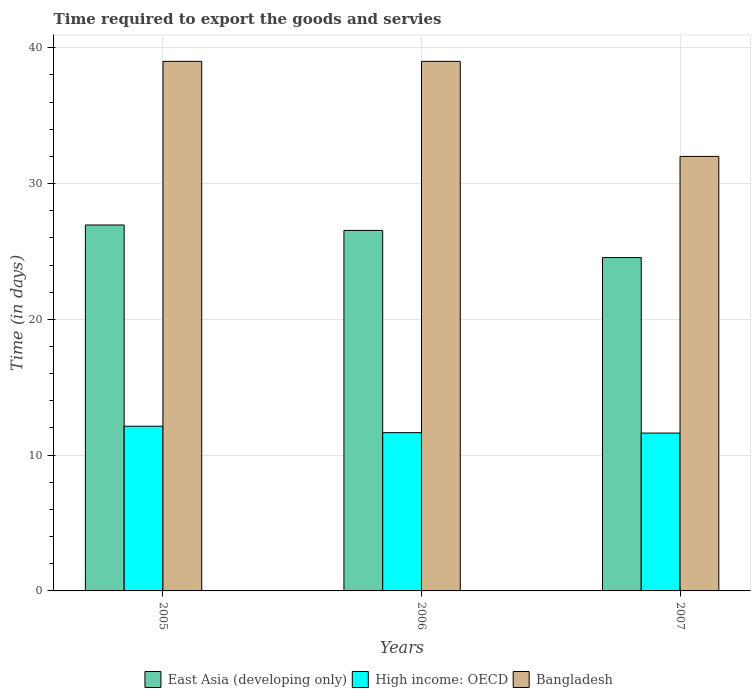Are the number of bars per tick equal to the number of legend labels?
Offer a very short reply. Yes. How many bars are there on the 3rd tick from the left?
Make the answer very short. 3. What is the label of the 1st group of bars from the left?
Your answer should be compact. 2005. In how many cases, is the number of bars for a given year not equal to the number of legend labels?
Offer a terse response. 0. What is the number of days required to export the goods and services in High income: OECD in 2006?
Give a very brief answer. 11.66. Across all years, what is the minimum number of days required to export the goods and services in High income: OECD?
Give a very brief answer. 11.62. In which year was the number of days required to export the goods and services in Bangladesh maximum?
Offer a very short reply. 2005. In which year was the number of days required to export the goods and services in East Asia (developing only) minimum?
Keep it short and to the point. 2007. What is the total number of days required to export the goods and services in High income: OECD in the graph?
Keep it short and to the point. 35.41. What is the difference between the number of days required to export the goods and services in High income: OECD in 2005 and that in 2007?
Ensure brevity in your answer.  0.5. What is the difference between the number of days required to export the goods and services in Bangladesh in 2005 and the number of days required to export the goods and services in High income: OECD in 2006?
Provide a succinct answer. 27.34. What is the average number of days required to export the goods and services in Bangladesh per year?
Ensure brevity in your answer.  36.67. In the year 2007, what is the difference between the number of days required to export the goods and services in East Asia (developing only) and number of days required to export the goods and services in Bangladesh?
Your answer should be very brief. -7.45. In how many years, is the number of days required to export the goods and services in East Asia (developing only) greater than 32 days?
Give a very brief answer. 0. What is the ratio of the number of days required to export the goods and services in East Asia (developing only) in 2005 to that in 2006?
Offer a terse response. 1.02. What is the difference between the highest and the lowest number of days required to export the goods and services in High income: OECD?
Offer a very short reply. 0.5. What does the 2nd bar from the right in 2006 represents?
Make the answer very short. High income: OECD. How many bars are there?
Give a very brief answer. 9. How many years are there in the graph?
Provide a succinct answer. 3. Are the values on the major ticks of Y-axis written in scientific E-notation?
Offer a very short reply. No. Does the graph contain any zero values?
Provide a succinct answer. No. Where does the legend appear in the graph?
Your answer should be compact. Bottom center. How many legend labels are there?
Make the answer very short. 3. What is the title of the graph?
Provide a succinct answer. Time required to export the goods and servies. What is the label or title of the Y-axis?
Provide a succinct answer. Time (in days). What is the Time (in days) of East Asia (developing only) in 2005?
Your answer should be compact. 26.95. What is the Time (in days) of High income: OECD in 2005?
Provide a short and direct response. 12.13. What is the Time (in days) in Bangladesh in 2005?
Your response must be concise. 39. What is the Time (in days) of East Asia (developing only) in 2006?
Provide a succinct answer. 26.55. What is the Time (in days) of High income: OECD in 2006?
Ensure brevity in your answer.  11.66. What is the Time (in days) of East Asia (developing only) in 2007?
Keep it short and to the point. 24.55. What is the Time (in days) of High income: OECD in 2007?
Your answer should be very brief. 11.62. What is the Time (in days) in Bangladesh in 2007?
Offer a very short reply. 32. Across all years, what is the maximum Time (in days) of East Asia (developing only)?
Offer a very short reply. 26.95. Across all years, what is the maximum Time (in days) of High income: OECD?
Provide a short and direct response. 12.13. Across all years, what is the maximum Time (in days) of Bangladesh?
Your answer should be very brief. 39. Across all years, what is the minimum Time (in days) of East Asia (developing only)?
Give a very brief answer. 24.55. Across all years, what is the minimum Time (in days) of High income: OECD?
Ensure brevity in your answer.  11.62. Across all years, what is the minimum Time (in days) in Bangladesh?
Your answer should be very brief. 32. What is the total Time (in days) of East Asia (developing only) in the graph?
Keep it short and to the point. 78.05. What is the total Time (in days) of High income: OECD in the graph?
Provide a succinct answer. 35.41. What is the total Time (in days) in Bangladesh in the graph?
Your response must be concise. 110. What is the difference between the Time (in days) in High income: OECD in 2005 and that in 2006?
Your answer should be very brief. 0.47. What is the difference between the Time (in days) of Bangladesh in 2005 and that in 2006?
Ensure brevity in your answer.  0. What is the difference between the Time (in days) of East Asia (developing only) in 2005 and that in 2007?
Give a very brief answer. 2.4. What is the difference between the Time (in days) in High income: OECD in 2005 and that in 2007?
Provide a succinct answer. 0.5. What is the difference between the Time (in days) in Bangladesh in 2005 and that in 2007?
Your response must be concise. 7. What is the difference between the Time (in days) of East Asia (developing only) in 2006 and that in 2007?
Provide a succinct answer. 2. What is the difference between the Time (in days) in High income: OECD in 2006 and that in 2007?
Provide a succinct answer. 0.03. What is the difference between the Time (in days) in East Asia (developing only) in 2005 and the Time (in days) in High income: OECD in 2006?
Your answer should be very brief. 15.29. What is the difference between the Time (in days) in East Asia (developing only) in 2005 and the Time (in days) in Bangladesh in 2006?
Provide a short and direct response. -12.05. What is the difference between the Time (in days) of High income: OECD in 2005 and the Time (in days) of Bangladesh in 2006?
Your response must be concise. -26.87. What is the difference between the Time (in days) of East Asia (developing only) in 2005 and the Time (in days) of High income: OECD in 2007?
Your response must be concise. 15.32. What is the difference between the Time (in days) in East Asia (developing only) in 2005 and the Time (in days) in Bangladesh in 2007?
Offer a very short reply. -5.05. What is the difference between the Time (in days) in High income: OECD in 2005 and the Time (in days) in Bangladesh in 2007?
Ensure brevity in your answer.  -19.87. What is the difference between the Time (in days) of East Asia (developing only) in 2006 and the Time (in days) of High income: OECD in 2007?
Offer a terse response. 14.93. What is the difference between the Time (in days) of East Asia (developing only) in 2006 and the Time (in days) of Bangladesh in 2007?
Offer a terse response. -5.45. What is the difference between the Time (in days) in High income: OECD in 2006 and the Time (in days) in Bangladesh in 2007?
Ensure brevity in your answer.  -20.34. What is the average Time (in days) in East Asia (developing only) per year?
Make the answer very short. 26.02. What is the average Time (in days) of High income: OECD per year?
Provide a short and direct response. 11.8. What is the average Time (in days) of Bangladesh per year?
Provide a succinct answer. 36.67. In the year 2005, what is the difference between the Time (in days) of East Asia (developing only) and Time (in days) of High income: OECD?
Keep it short and to the point. 14.82. In the year 2005, what is the difference between the Time (in days) of East Asia (developing only) and Time (in days) of Bangladesh?
Ensure brevity in your answer.  -12.05. In the year 2005, what is the difference between the Time (in days) of High income: OECD and Time (in days) of Bangladesh?
Offer a terse response. -26.87. In the year 2006, what is the difference between the Time (in days) of East Asia (developing only) and Time (in days) of High income: OECD?
Your answer should be very brief. 14.89. In the year 2006, what is the difference between the Time (in days) in East Asia (developing only) and Time (in days) in Bangladesh?
Keep it short and to the point. -12.45. In the year 2006, what is the difference between the Time (in days) in High income: OECD and Time (in days) in Bangladesh?
Provide a succinct answer. -27.34. In the year 2007, what is the difference between the Time (in days) in East Asia (developing only) and Time (in days) in High income: OECD?
Your answer should be very brief. 12.93. In the year 2007, what is the difference between the Time (in days) in East Asia (developing only) and Time (in days) in Bangladesh?
Your answer should be compact. -7.45. In the year 2007, what is the difference between the Time (in days) in High income: OECD and Time (in days) in Bangladesh?
Your answer should be compact. -20.38. What is the ratio of the Time (in days) of East Asia (developing only) in 2005 to that in 2006?
Your answer should be compact. 1.02. What is the ratio of the Time (in days) in High income: OECD in 2005 to that in 2006?
Your response must be concise. 1.04. What is the ratio of the Time (in days) in Bangladesh in 2005 to that in 2006?
Your answer should be compact. 1. What is the ratio of the Time (in days) of East Asia (developing only) in 2005 to that in 2007?
Keep it short and to the point. 1.1. What is the ratio of the Time (in days) of High income: OECD in 2005 to that in 2007?
Provide a succinct answer. 1.04. What is the ratio of the Time (in days) in Bangladesh in 2005 to that in 2007?
Provide a succinct answer. 1.22. What is the ratio of the Time (in days) of East Asia (developing only) in 2006 to that in 2007?
Your answer should be very brief. 1.08. What is the ratio of the Time (in days) in Bangladesh in 2006 to that in 2007?
Ensure brevity in your answer.  1.22. What is the difference between the highest and the second highest Time (in days) of East Asia (developing only)?
Offer a very short reply. 0.4. What is the difference between the highest and the second highest Time (in days) of High income: OECD?
Provide a succinct answer. 0.47. What is the difference between the highest and the lowest Time (in days) in East Asia (developing only)?
Your answer should be compact. 2.4. What is the difference between the highest and the lowest Time (in days) of High income: OECD?
Offer a very short reply. 0.5. What is the difference between the highest and the lowest Time (in days) of Bangladesh?
Provide a succinct answer. 7. 